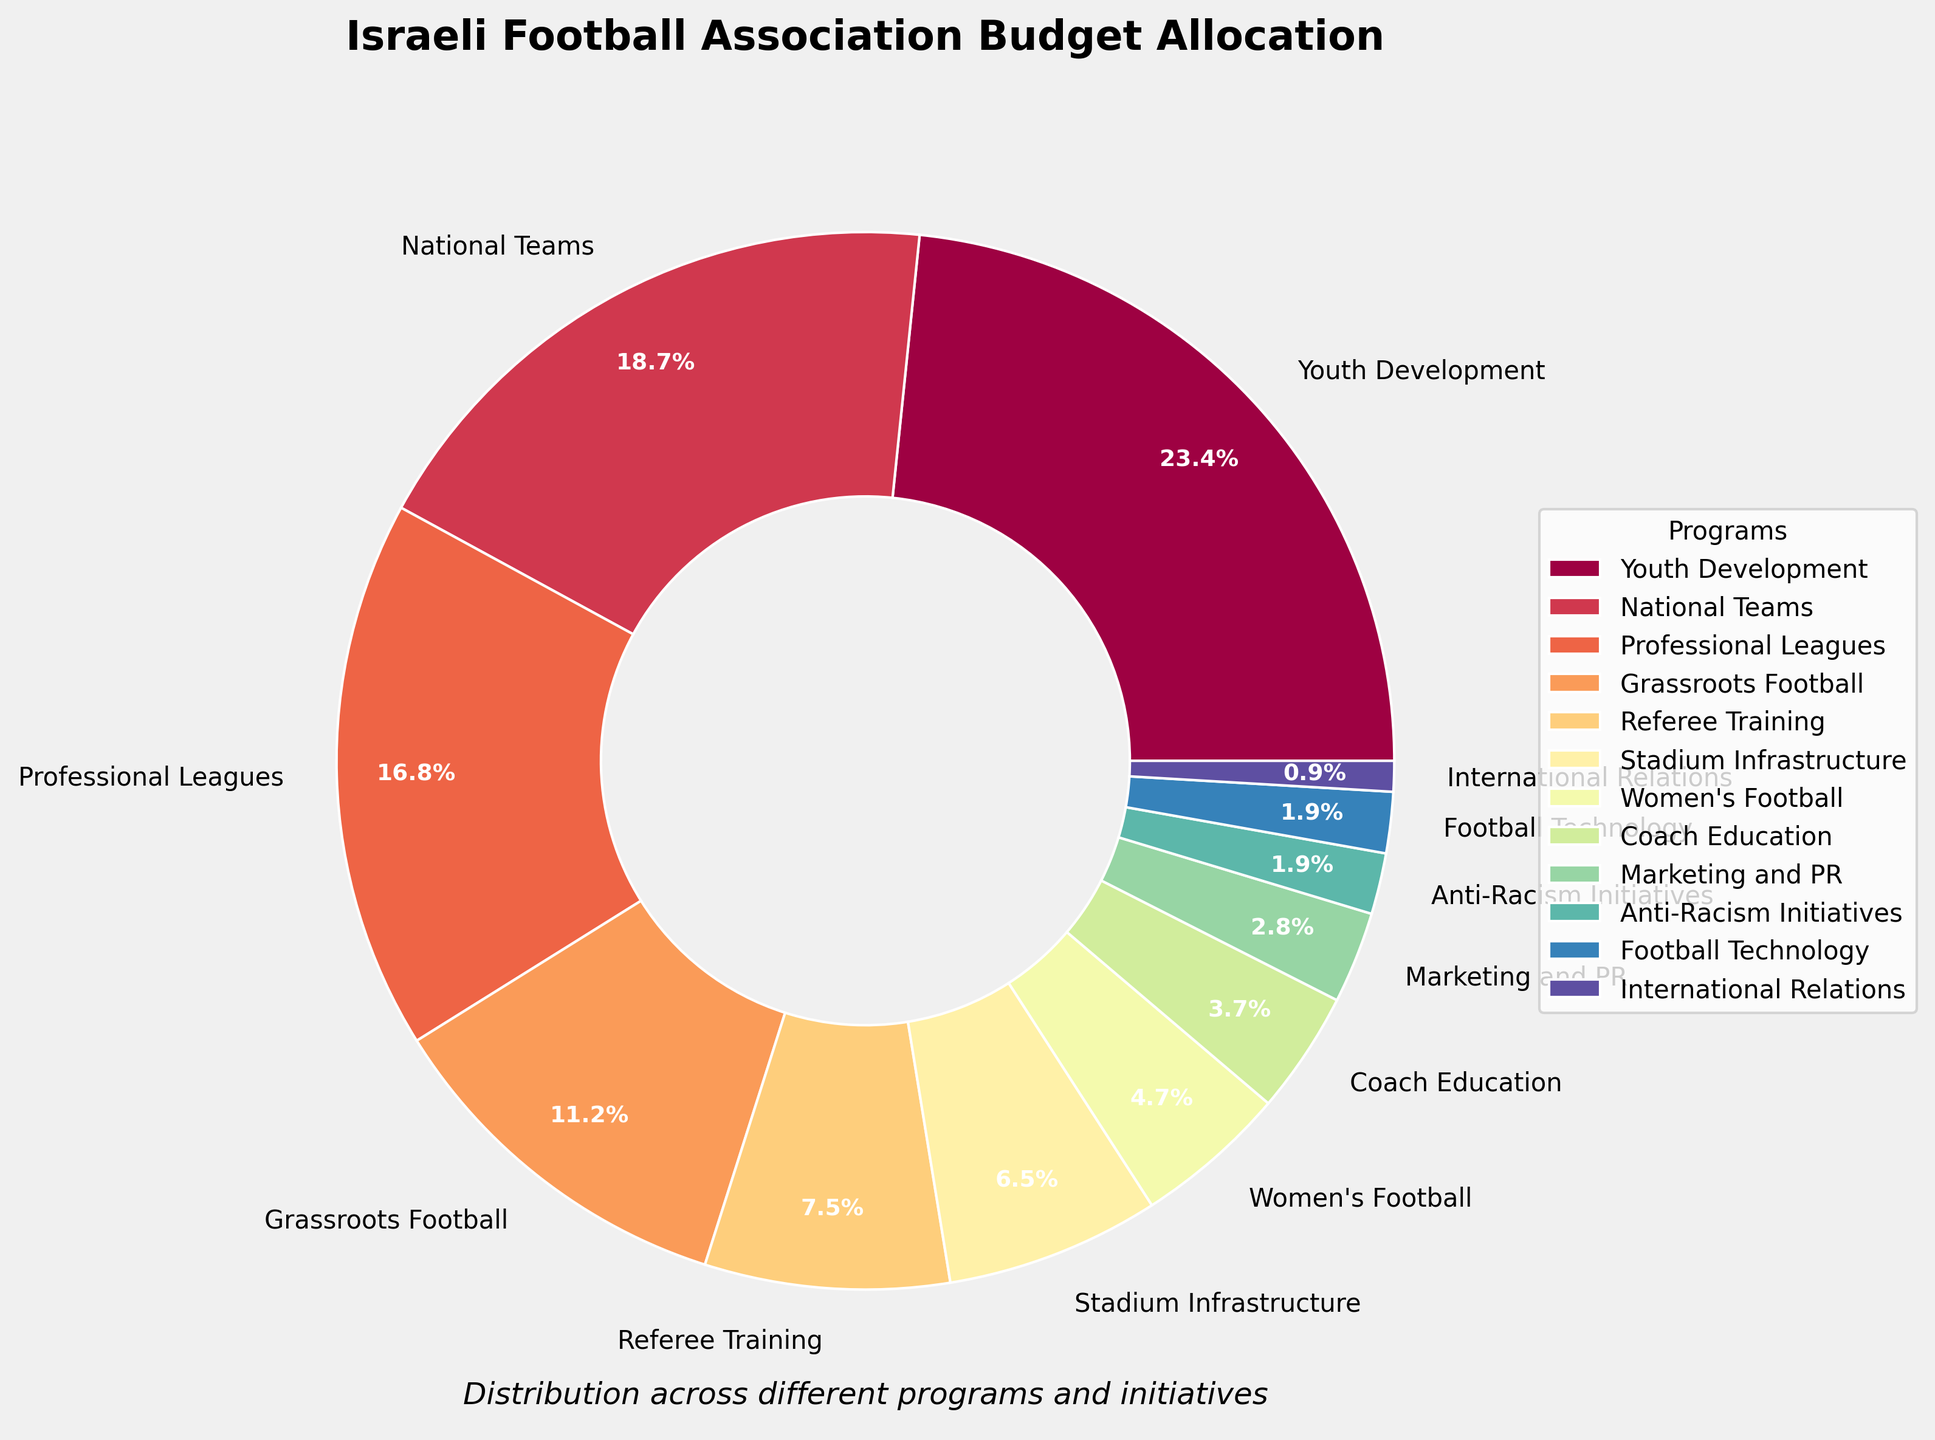Which program receives the highest percentage of the budget? By looking at the pie chart, identify the segment with the largest section, which corresponds to Youth Development at 25%.
Answer: Youth Development How much more percentage is allocated to National Teams compared to Women's Football? The pie chart shows National Teams at 20% and Women's Football at 5%. Subtract the budget of Women's Football from National Teams to get 15%.
Answer: 15% Which areas together receive the same percentage as Youth Development? Youth Development receives 25%. Combine the percentages of Referee Training (8%), Stadium Infrastructure (7%), Women's Football (5%), Coach Education (4%), and Marketing and PR (3%). Summing them gives 27%, which is close to 25%.
Answer: Referee Training, Stadium Infrastructure, Women's Football, Coach Education, and Marketing and PR By what percentage is Grassroots Football larger than Anti-Racism Initiatives? Grassroots Football receives 12% and Anti-Racism Initiatives 2%. Subtract 2% from 12% to find the difference, which is 10%.
Answer: 10% Which programs receive less than 5% of the budget? Look at the pie chart sections labeled at less than 5%. These are Coach Education (4%), Marketing and PR (3%), Anti-Racism Initiatives (2%), Football Technology (2%), and International Relations (1%).
Answer: Coach Education, Marketing and PR, Anti-Racism Initiatives, Football Technology, International Relations Is the budget for Professional Leagues greater than the sum of the budgets for Stadium Infrastructure and Coach Education? Professional Leagues are allocated 18%. Sum the budgets for Stadium Infrastructure (7%) and Coach Education (4%) to get 11%. Since 18% is greater than 11%, the answer is yes.
Answer: Yes Which category is closest in percentage allocation to Women's Football? Women's Football has a 5% allocation. The closest percentage to this value is Coach Education at 4%.
Answer: Coach Education How much of the budget is allocated to programs promoting gender equality (assuming Women's Football and Anti-Racism Initiatives contribute to this)? Women's Football receives 5%, and Anti-Racism Initiatives receive 2%. Summing these gives a total of 7%.
Answer: 7% Compare the combined budget of Football Technology and International Relations with the allocation for Marketing and PR. Football Technology and International Relations receive 2% and 1%, respectively, summing to 3%. Marketing and PR also receive 3%. Thus, they are equal.
Answer: Equal 